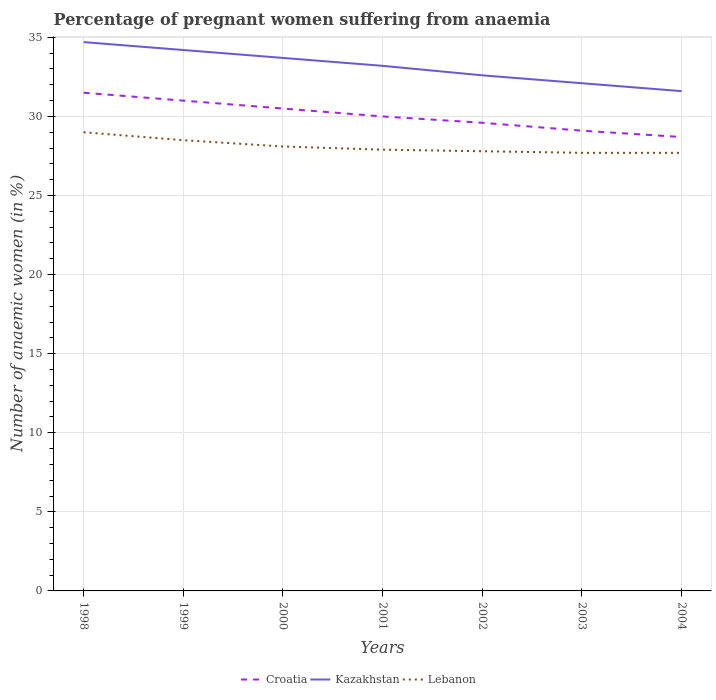How many different coloured lines are there?
Your answer should be compact. 3. Does the line corresponding to Lebanon intersect with the line corresponding to Kazakhstan?
Provide a succinct answer. No. Across all years, what is the maximum number of anaemic women in Lebanon?
Keep it short and to the point. 27.7. In which year was the number of anaemic women in Lebanon maximum?
Offer a very short reply. 2003. What is the total number of anaemic women in Kazakhstan in the graph?
Offer a terse response. 1. What is the difference between the highest and the second highest number of anaemic women in Croatia?
Give a very brief answer. 2.8. How many years are there in the graph?
Your answer should be very brief. 7. Are the values on the major ticks of Y-axis written in scientific E-notation?
Offer a very short reply. No. Does the graph contain any zero values?
Your answer should be compact. No. How are the legend labels stacked?
Provide a succinct answer. Horizontal. What is the title of the graph?
Offer a terse response. Percentage of pregnant women suffering from anaemia. What is the label or title of the X-axis?
Provide a short and direct response. Years. What is the label or title of the Y-axis?
Offer a very short reply. Number of anaemic women (in %). What is the Number of anaemic women (in %) of Croatia in 1998?
Keep it short and to the point. 31.5. What is the Number of anaemic women (in %) in Kazakhstan in 1998?
Ensure brevity in your answer.  34.7. What is the Number of anaemic women (in %) in Croatia in 1999?
Offer a terse response. 31. What is the Number of anaemic women (in %) in Kazakhstan in 1999?
Give a very brief answer. 34.2. What is the Number of anaemic women (in %) in Lebanon in 1999?
Your answer should be very brief. 28.5. What is the Number of anaemic women (in %) of Croatia in 2000?
Keep it short and to the point. 30.5. What is the Number of anaemic women (in %) of Kazakhstan in 2000?
Your response must be concise. 33.7. What is the Number of anaemic women (in %) of Lebanon in 2000?
Your answer should be compact. 28.1. What is the Number of anaemic women (in %) of Croatia in 2001?
Ensure brevity in your answer.  30. What is the Number of anaemic women (in %) in Kazakhstan in 2001?
Keep it short and to the point. 33.2. What is the Number of anaemic women (in %) of Lebanon in 2001?
Your answer should be very brief. 27.9. What is the Number of anaemic women (in %) in Croatia in 2002?
Give a very brief answer. 29.6. What is the Number of anaemic women (in %) of Kazakhstan in 2002?
Keep it short and to the point. 32.6. What is the Number of anaemic women (in %) of Lebanon in 2002?
Your answer should be compact. 27.8. What is the Number of anaemic women (in %) of Croatia in 2003?
Your response must be concise. 29.1. What is the Number of anaemic women (in %) of Kazakhstan in 2003?
Offer a very short reply. 32.1. What is the Number of anaemic women (in %) of Lebanon in 2003?
Your answer should be very brief. 27.7. What is the Number of anaemic women (in %) in Croatia in 2004?
Provide a short and direct response. 28.7. What is the Number of anaemic women (in %) in Kazakhstan in 2004?
Provide a succinct answer. 31.6. What is the Number of anaemic women (in %) of Lebanon in 2004?
Provide a short and direct response. 27.7. Across all years, what is the maximum Number of anaemic women (in %) in Croatia?
Offer a very short reply. 31.5. Across all years, what is the maximum Number of anaemic women (in %) in Kazakhstan?
Keep it short and to the point. 34.7. Across all years, what is the maximum Number of anaemic women (in %) of Lebanon?
Ensure brevity in your answer.  29. Across all years, what is the minimum Number of anaemic women (in %) of Croatia?
Offer a terse response. 28.7. Across all years, what is the minimum Number of anaemic women (in %) in Kazakhstan?
Offer a very short reply. 31.6. Across all years, what is the minimum Number of anaemic women (in %) in Lebanon?
Give a very brief answer. 27.7. What is the total Number of anaemic women (in %) of Croatia in the graph?
Ensure brevity in your answer.  210.4. What is the total Number of anaemic women (in %) of Kazakhstan in the graph?
Offer a very short reply. 232.1. What is the total Number of anaemic women (in %) of Lebanon in the graph?
Offer a very short reply. 196.7. What is the difference between the Number of anaemic women (in %) of Croatia in 1998 and that in 1999?
Your answer should be compact. 0.5. What is the difference between the Number of anaemic women (in %) of Croatia in 1998 and that in 2000?
Your answer should be compact. 1. What is the difference between the Number of anaemic women (in %) of Kazakhstan in 1998 and that in 2000?
Your answer should be compact. 1. What is the difference between the Number of anaemic women (in %) in Lebanon in 1998 and that in 2000?
Your answer should be very brief. 0.9. What is the difference between the Number of anaemic women (in %) of Lebanon in 1998 and that in 2001?
Make the answer very short. 1.1. What is the difference between the Number of anaemic women (in %) of Croatia in 1998 and that in 2002?
Offer a very short reply. 1.9. What is the difference between the Number of anaemic women (in %) in Lebanon in 1998 and that in 2002?
Offer a very short reply. 1.2. What is the difference between the Number of anaemic women (in %) of Lebanon in 1998 and that in 2003?
Give a very brief answer. 1.3. What is the difference between the Number of anaemic women (in %) in Lebanon in 1999 and that in 2000?
Ensure brevity in your answer.  0.4. What is the difference between the Number of anaemic women (in %) in Kazakhstan in 1999 and that in 2001?
Offer a very short reply. 1. What is the difference between the Number of anaemic women (in %) of Croatia in 1999 and that in 2002?
Your answer should be very brief. 1.4. What is the difference between the Number of anaemic women (in %) in Lebanon in 1999 and that in 2002?
Your response must be concise. 0.7. What is the difference between the Number of anaemic women (in %) of Lebanon in 1999 and that in 2003?
Your response must be concise. 0.8. What is the difference between the Number of anaemic women (in %) in Croatia in 1999 and that in 2004?
Your response must be concise. 2.3. What is the difference between the Number of anaemic women (in %) of Kazakhstan in 1999 and that in 2004?
Offer a terse response. 2.6. What is the difference between the Number of anaemic women (in %) in Kazakhstan in 2000 and that in 2001?
Your response must be concise. 0.5. What is the difference between the Number of anaemic women (in %) in Kazakhstan in 2000 and that in 2002?
Your answer should be compact. 1.1. What is the difference between the Number of anaemic women (in %) of Lebanon in 2000 and that in 2003?
Your response must be concise. 0.4. What is the difference between the Number of anaemic women (in %) in Croatia in 2000 and that in 2004?
Offer a terse response. 1.8. What is the difference between the Number of anaemic women (in %) in Kazakhstan in 2000 and that in 2004?
Provide a succinct answer. 2.1. What is the difference between the Number of anaemic women (in %) in Lebanon in 2000 and that in 2004?
Offer a very short reply. 0.4. What is the difference between the Number of anaemic women (in %) in Croatia in 2001 and that in 2002?
Your answer should be very brief. 0.4. What is the difference between the Number of anaemic women (in %) in Lebanon in 2001 and that in 2002?
Give a very brief answer. 0.1. What is the difference between the Number of anaemic women (in %) in Croatia in 2001 and that in 2003?
Your answer should be very brief. 0.9. What is the difference between the Number of anaemic women (in %) in Kazakhstan in 2001 and that in 2003?
Offer a terse response. 1.1. What is the difference between the Number of anaemic women (in %) in Lebanon in 2001 and that in 2003?
Give a very brief answer. 0.2. What is the difference between the Number of anaemic women (in %) of Kazakhstan in 2002 and that in 2004?
Give a very brief answer. 1. What is the difference between the Number of anaemic women (in %) in Lebanon in 2002 and that in 2004?
Provide a succinct answer. 0.1. What is the difference between the Number of anaemic women (in %) in Croatia in 2003 and that in 2004?
Provide a succinct answer. 0.4. What is the difference between the Number of anaemic women (in %) in Lebanon in 2003 and that in 2004?
Make the answer very short. 0. What is the difference between the Number of anaemic women (in %) of Croatia in 1998 and the Number of anaemic women (in %) of Kazakhstan in 1999?
Keep it short and to the point. -2.7. What is the difference between the Number of anaemic women (in %) of Croatia in 1998 and the Number of anaemic women (in %) of Lebanon in 1999?
Provide a succinct answer. 3. What is the difference between the Number of anaemic women (in %) in Kazakhstan in 1998 and the Number of anaemic women (in %) in Lebanon in 1999?
Make the answer very short. 6.2. What is the difference between the Number of anaemic women (in %) in Kazakhstan in 1998 and the Number of anaemic women (in %) in Lebanon in 2000?
Your response must be concise. 6.6. What is the difference between the Number of anaemic women (in %) in Croatia in 1998 and the Number of anaemic women (in %) in Kazakhstan in 2001?
Offer a terse response. -1.7. What is the difference between the Number of anaemic women (in %) of Croatia in 1998 and the Number of anaemic women (in %) of Lebanon in 2001?
Your answer should be very brief. 3.6. What is the difference between the Number of anaemic women (in %) of Kazakhstan in 1998 and the Number of anaemic women (in %) of Lebanon in 2001?
Give a very brief answer. 6.8. What is the difference between the Number of anaemic women (in %) in Croatia in 1998 and the Number of anaemic women (in %) in Kazakhstan in 2003?
Make the answer very short. -0.6. What is the difference between the Number of anaemic women (in %) in Kazakhstan in 1998 and the Number of anaemic women (in %) in Lebanon in 2004?
Give a very brief answer. 7. What is the difference between the Number of anaemic women (in %) in Croatia in 1999 and the Number of anaemic women (in %) in Kazakhstan in 2000?
Your response must be concise. -2.7. What is the difference between the Number of anaemic women (in %) in Croatia in 1999 and the Number of anaemic women (in %) in Lebanon in 2000?
Provide a succinct answer. 2.9. What is the difference between the Number of anaemic women (in %) in Croatia in 1999 and the Number of anaemic women (in %) in Kazakhstan in 2001?
Provide a succinct answer. -2.2. What is the difference between the Number of anaemic women (in %) of Croatia in 1999 and the Number of anaemic women (in %) of Kazakhstan in 2002?
Your response must be concise. -1.6. What is the difference between the Number of anaemic women (in %) of Kazakhstan in 1999 and the Number of anaemic women (in %) of Lebanon in 2002?
Keep it short and to the point. 6.4. What is the difference between the Number of anaemic women (in %) of Croatia in 1999 and the Number of anaemic women (in %) of Kazakhstan in 2003?
Keep it short and to the point. -1.1. What is the difference between the Number of anaemic women (in %) in Croatia in 1999 and the Number of anaemic women (in %) in Kazakhstan in 2004?
Keep it short and to the point. -0.6. What is the difference between the Number of anaemic women (in %) of Croatia in 1999 and the Number of anaemic women (in %) of Lebanon in 2004?
Keep it short and to the point. 3.3. What is the difference between the Number of anaemic women (in %) in Kazakhstan in 1999 and the Number of anaemic women (in %) in Lebanon in 2004?
Provide a short and direct response. 6.5. What is the difference between the Number of anaemic women (in %) in Croatia in 2000 and the Number of anaemic women (in %) in Kazakhstan in 2001?
Offer a very short reply. -2.7. What is the difference between the Number of anaemic women (in %) in Croatia in 2000 and the Number of anaemic women (in %) in Lebanon in 2003?
Make the answer very short. 2.8. What is the difference between the Number of anaemic women (in %) in Kazakhstan in 2000 and the Number of anaemic women (in %) in Lebanon in 2003?
Your response must be concise. 6. What is the difference between the Number of anaemic women (in %) in Croatia in 2000 and the Number of anaemic women (in %) in Lebanon in 2004?
Provide a succinct answer. 2.8. What is the difference between the Number of anaemic women (in %) in Croatia in 2001 and the Number of anaemic women (in %) in Kazakhstan in 2002?
Your response must be concise. -2.6. What is the difference between the Number of anaemic women (in %) of Croatia in 2001 and the Number of anaemic women (in %) of Lebanon in 2002?
Make the answer very short. 2.2. What is the difference between the Number of anaemic women (in %) in Kazakhstan in 2001 and the Number of anaemic women (in %) in Lebanon in 2002?
Keep it short and to the point. 5.4. What is the difference between the Number of anaemic women (in %) in Croatia in 2001 and the Number of anaemic women (in %) in Kazakhstan in 2003?
Ensure brevity in your answer.  -2.1. What is the difference between the Number of anaemic women (in %) in Kazakhstan in 2001 and the Number of anaemic women (in %) in Lebanon in 2003?
Offer a terse response. 5.5. What is the difference between the Number of anaemic women (in %) in Croatia in 2001 and the Number of anaemic women (in %) in Lebanon in 2004?
Offer a terse response. 2.3. What is the difference between the Number of anaemic women (in %) of Kazakhstan in 2001 and the Number of anaemic women (in %) of Lebanon in 2004?
Provide a short and direct response. 5.5. What is the difference between the Number of anaemic women (in %) in Croatia in 2002 and the Number of anaemic women (in %) in Lebanon in 2004?
Offer a terse response. 1.9. What is the difference between the Number of anaemic women (in %) in Croatia in 2003 and the Number of anaemic women (in %) in Kazakhstan in 2004?
Provide a short and direct response. -2.5. What is the difference between the Number of anaemic women (in %) of Croatia in 2003 and the Number of anaemic women (in %) of Lebanon in 2004?
Your answer should be very brief. 1.4. What is the average Number of anaemic women (in %) of Croatia per year?
Your answer should be very brief. 30.06. What is the average Number of anaemic women (in %) in Kazakhstan per year?
Ensure brevity in your answer.  33.16. What is the average Number of anaemic women (in %) of Lebanon per year?
Provide a short and direct response. 28.1. In the year 1999, what is the difference between the Number of anaemic women (in %) in Croatia and Number of anaemic women (in %) in Kazakhstan?
Your answer should be very brief. -3.2. In the year 2000, what is the difference between the Number of anaemic women (in %) of Croatia and Number of anaemic women (in %) of Kazakhstan?
Your answer should be very brief. -3.2. In the year 2000, what is the difference between the Number of anaemic women (in %) of Croatia and Number of anaemic women (in %) of Lebanon?
Offer a very short reply. 2.4. In the year 2001, what is the difference between the Number of anaemic women (in %) of Croatia and Number of anaemic women (in %) of Kazakhstan?
Offer a very short reply. -3.2. In the year 2001, what is the difference between the Number of anaemic women (in %) in Kazakhstan and Number of anaemic women (in %) in Lebanon?
Give a very brief answer. 5.3. In the year 2004, what is the difference between the Number of anaemic women (in %) in Croatia and Number of anaemic women (in %) in Kazakhstan?
Keep it short and to the point. -2.9. In the year 2004, what is the difference between the Number of anaemic women (in %) of Kazakhstan and Number of anaemic women (in %) of Lebanon?
Offer a terse response. 3.9. What is the ratio of the Number of anaemic women (in %) of Croatia in 1998 to that in 1999?
Give a very brief answer. 1.02. What is the ratio of the Number of anaemic women (in %) in Kazakhstan in 1998 to that in 1999?
Keep it short and to the point. 1.01. What is the ratio of the Number of anaemic women (in %) in Lebanon in 1998 to that in 1999?
Keep it short and to the point. 1.02. What is the ratio of the Number of anaemic women (in %) of Croatia in 1998 to that in 2000?
Make the answer very short. 1.03. What is the ratio of the Number of anaemic women (in %) of Kazakhstan in 1998 to that in 2000?
Provide a short and direct response. 1.03. What is the ratio of the Number of anaemic women (in %) in Lebanon in 1998 to that in 2000?
Your answer should be very brief. 1.03. What is the ratio of the Number of anaemic women (in %) in Kazakhstan in 1998 to that in 2001?
Keep it short and to the point. 1.05. What is the ratio of the Number of anaemic women (in %) of Lebanon in 1998 to that in 2001?
Your answer should be very brief. 1.04. What is the ratio of the Number of anaemic women (in %) in Croatia in 1998 to that in 2002?
Offer a very short reply. 1.06. What is the ratio of the Number of anaemic women (in %) of Kazakhstan in 1998 to that in 2002?
Your response must be concise. 1.06. What is the ratio of the Number of anaemic women (in %) in Lebanon in 1998 to that in 2002?
Provide a short and direct response. 1.04. What is the ratio of the Number of anaemic women (in %) in Croatia in 1998 to that in 2003?
Provide a succinct answer. 1.08. What is the ratio of the Number of anaemic women (in %) in Kazakhstan in 1998 to that in 2003?
Your answer should be very brief. 1.08. What is the ratio of the Number of anaemic women (in %) of Lebanon in 1998 to that in 2003?
Give a very brief answer. 1.05. What is the ratio of the Number of anaemic women (in %) of Croatia in 1998 to that in 2004?
Give a very brief answer. 1.1. What is the ratio of the Number of anaemic women (in %) in Kazakhstan in 1998 to that in 2004?
Ensure brevity in your answer.  1.1. What is the ratio of the Number of anaemic women (in %) of Lebanon in 1998 to that in 2004?
Your answer should be compact. 1.05. What is the ratio of the Number of anaemic women (in %) of Croatia in 1999 to that in 2000?
Your answer should be compact. 1.02. What is the ratio of the Number of anaemic women (in %) in Kazakhstan in 1999 to that in 2000?
Ensure brevity in your answer.  1.01. What is the ratio of the Number of anaemic women (in %) of Lebanon in 1999 to that in 2000?
Keep it short and to the point. 1.01. What is the ratio of the Number of anaemic women (in %) in Croatia in 1999 to that in 2001?
Make the answer very short. 1.03. What is the ratio of the Number of anaemic women (in %) of Kazakhstan in 1999 to that in 2001?
Your answer should be very brief. 1.03. What is the ratio of the Number of anaemic women (in %) of Lebanon in 1999 to that in 2001?
Offer a very short reply. 1.02. What is the ratio of the Number of anaemic women (in %) of Croatia in 1999 to that in 2002?
Give a very brief answer. 1.05. What is the ratio of the Number of anaemic women (in %) in Kazakhstan in 1999 to that in 2002?
Offer a terse response. 1.05. What is the ratio of the Number of anaemic women (in %) of Lebanon in 1999 to that in 2002?
Keep it short and to the point. 1.03. What is the ratio of the Number of anaemic women (in %) in Croatia in 1999 to that in 2003?
Offer a very short reply. 1.07. What is the ratio of the Number of anaemic women (in %) in Kazakhstan in 1999 to that in 2003?
Make the answer very short. 1.07. What is the ratio of the Number of anaemic women (in %) of Lebanon in 1999 to that in 2003?
Your response must be concise. 1.03. What is the ratio of the Number of anaemic women (in %) in Croatia in 1999 to that in 2004?
Your response must be concise. 1.08. What is the ratio of the Number of anaemic women (in %) in Kazakhstan in 1999 to that in 2004?
Offer a very short reply. 1.08. What is the ratio of the Number of anaemic women (in %) in Lebanon in 1999 to that in 2004?
Offer a terse response. 1.03. What is the ratio of the Number of anaemic women (in %) of Croatia in 2000 to that in 2001?
Give a very brief answer. 1.02. What is the ratio of the Number of anaemic women (in %) of Kazakhstan in 2000 to that in 2001?
Ensure brevity in your answer.  1.02. What is the ratio of the Number of anaemic women (in %) in Lebanon in 2000 to that in 2001?
Make the answer very short. 1.01. What is the ratio of the Number of anaemic women (in %) of Croatia in 2000 to that in 2002?
Offer a very short reply. 1.03. What is the ratio of the Number of anaemic women (in %) in Kazakhstan in 2000 to that in 2002?
Your answer should be very brief. 1.03. What is the ratio of the Number of anaemic women (in %) of Lebanon in 2000 to that in 2002?
Provide a succinct answer. 1.01. What is the ratio of the Number of anaemic women (in %) in Croatia in 2000 to that in 2003?
Your answer should be very brief. 1.05. What is the ratio of the Number of anaemic women (in %) in Kazakhstan in 2000 to that in 2003?
Give a very brief answer. 1.05. What is the ratio of the Number of anaemic women (in %) in Lebanon in 2000 to that in 2003?
Provide a succinct answer. 1.01. What is the ratio of the Number of anaemic women (in %) of Croatia in 2000 to that in 2004?
Give a very brief answer. 1.06. What is the ratio of the Number of anaemic women (in %) in Kazakhstan in 2000 to that in 2004?
Your response must be concise. 1.07. What is the ratio of the Number of anaemic women (in %) of Lebanon in 2000 to that in 2004?
Offer a very short reply. 1.01. What is the ratio of the Number of anaemic women (in %) of Croatia in 2001 to that in 2002?
Your answer should be very brief. 1.01. What is the ratio of the Number of anaemic women (in %) of Kazakhstan in 2001 to that in 2002?
Provide a short and direct response. 1.02. What is the ratio of the Number of anaemic women (in %) in Croatia in 2001 to that in 2003?
Make the answer very short. 1.03. What is the ratio of the Number of anaemic women (in %) of Kazakhstan in 2001 to that in 2003?
Your answer should be very brief. 1.03. What is the ratio of the Number of anaemic women (in %) in Croatia in 2001 to that in 2004?
Provide a succinct answer. 1.05. What is the ratio of the Number of anaemic women (in %) in Kazakhstan in 2001 to that in 2004?
Ensure brevity in your answer.  1.05. What is the ratio of the Number of anaemic women (in %) of Croatia in 2002 to that in 2003?
Your answer should be compact. 1.02. What is the ratio of the Number of anaemic women (in %) of Kazakhstan in 2002 to that in 2003?
Your answer should be compact. 1.02. What is the ratio of the Number of anaemic women (in %) in Lebanon in 2002 to that in 2003?
Keep it short and to the point. 1. What is the ratio of the Number of anaemic women (in %) in Croatia in 2002 to that in 2004?
Provide a short and direct response. 1.03. What is the ratio of the Number of anaemic women (in %) of Kazakhstan in 2002 to that in 2004?
Ensure brevity in your answer.  1.03. What is the ratio of the Number of anaemic women (in %) of Lebanon in 2002 to that in 2004?
Give a very brief answer. 1. What is the ratio of the Number of anaemic women (in %) of Croatia in 2003 to that in 2004?
Provide a short and direct response. 1.01. What is the ratio of the Number of anaemic women (in %) of Kazakhstan in 2003 to that in 2004?
Provide a succinct answer. 1.02. What is the difference between the highest and the second highest Number of anaemic women (in %) in Lebanon?
Provide a short and direct response. 0.5. 